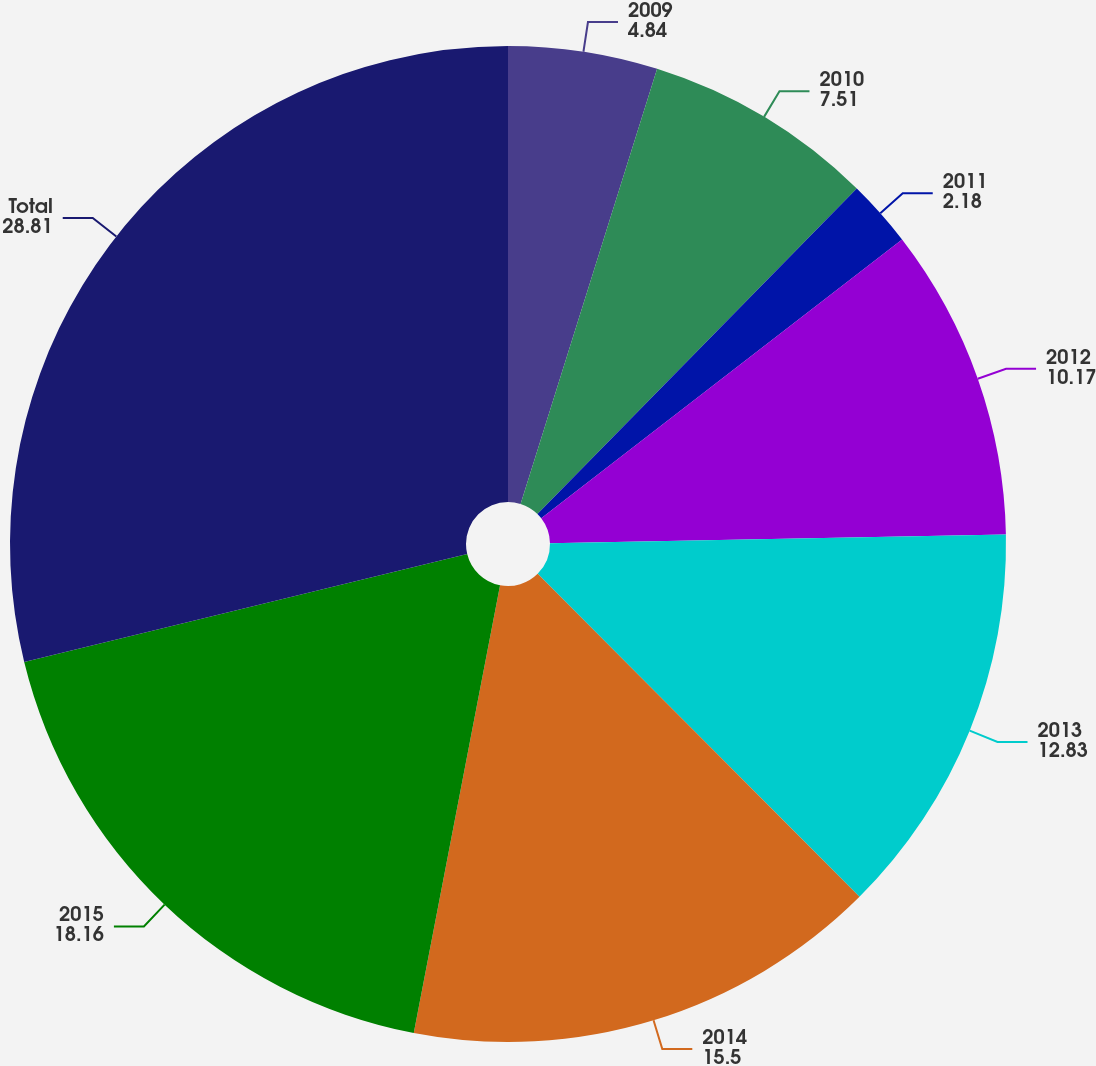Convert chart. <chart><loc_0><loc_0><loc_500><loc_500><pie_chart><fcel>2009<fcel>2010<fcel>2011<fcel>2012<fcel>2013<fcel>2014<fcel>2015<fcel>Total<nl><fcel>4.84%<fcel>7.51%<fcel>2.18%<fcel>10.17%<fcel>12.83%<fcel>15.5%<fcel>18.16%<fcel>28.81%<nl></chart> 